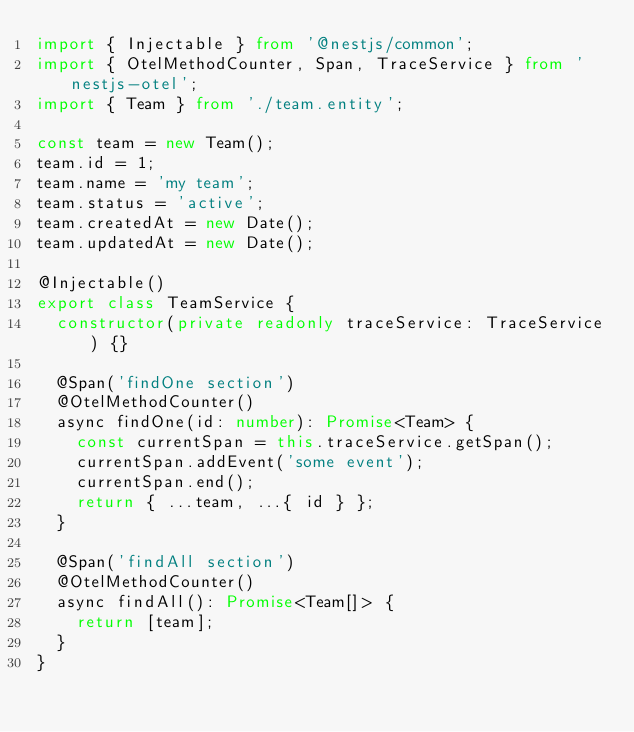<code> <loc_0><loc_0><loc_500><loc_500><_TypeScript_>import { Injectable } from '@nestjs/common';
import { OtelMethodCounter, Span, TraceService } from 'nestjs-otel';
import { Team } from './team.entity';

const team = new Team();
team.id = 1;
team.name = 'my team';
team.status = 'active';
team.createdAt = new Date();
team.updatedAt = new Date();

@Injectable()
export class TeamService {
  constructor(private readonly traceService: TraceService) {}

  @Span('findOne section')
  @OtelMethodCounter()
  async findOne(id: number): Promise<Team> {
    const currentSpan = this.traceService.getSpan();
    currentSpan.addEvent('some event');
    currentSpan.end();
    return { ...team, ...{ id } };
  }

  @Span('findAll section')
  @OtelMethodCounter()
  async findAll(): Promise<Team[]> {
    return [team];
  }
}
</code> 